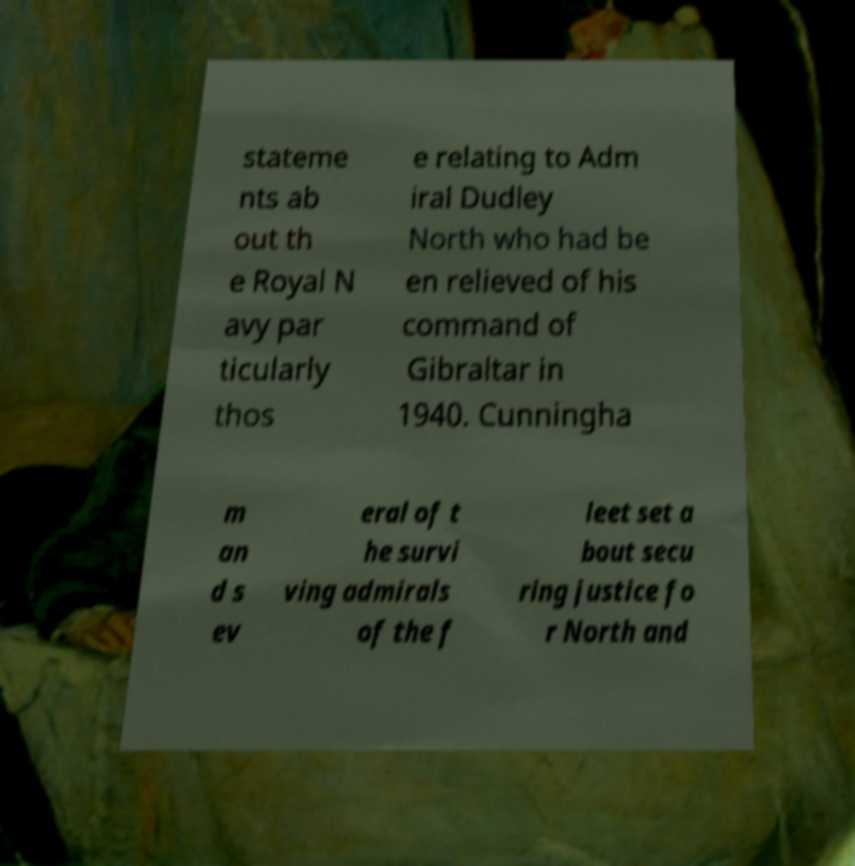Can you read and provide the text displayed in the image?This photo seems to have some interesting text. Can you extract and type it out for me? stateme nts ab out th e Royal N avy par ticularly thos e relating to Adm iral Dudley North who had be en relieved of his command of Gibraltar in 1940. Cunningha m an d s ev eral of t he survi ving admirals of the f leet set a bout secu ring justice fo r North and 